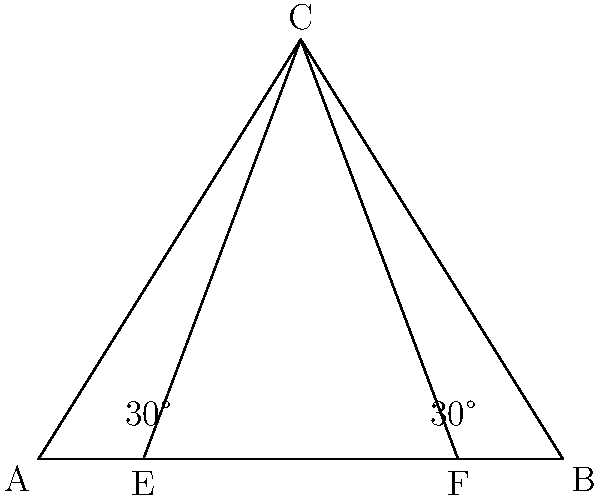In a theater, the stage is represented by line segment AB, which is 10 meters wide. The optimal viewing angle for audience members is 30° on either side of the center. If the apex of this viewing angle (point C) is 8 meters from the center of the stage, what is the maximum width of the seating area (EF) that allows all audience members to have an optimal view? Let's approach this step-by-step:

1) First, we need to identify the triangle formed by the viewing angles. This is an isosceles triangle ABC, where AC = BC.

2) We're given that AB = 10 meters and the height of the triangle (from C to the midpoint of AB) is 8 meters.

3) The angle at C is 60° (30° on each side of the center line).

4) We can split this isosceles triangle into two right triangles. Let's focus on one of these right triangles.

5) In this right triangle, we know:
   - The angle at C is 30°
   - The adjacent side (height) is 8 meters

6) We can use the tangent function to find half of AB:

   $$\tan(30°) = \frac{\text{opposite}}{\text{adjacent}} = \frac{\text{half of AB}}{8}$$

7) We know that $\tan(30°) = \frac{1}{\sqrt{3}}$, so:

   $$\frac{1}{\sqrt{3}} = \frac{\text{half of AB}}{8}$$

8) Solving for half of AB:

   $$\text{half of AB} = \frac{8}{\sqrt{3}} \approx 4.62 \text{ meters}$$

9) The full width of AB is twice this, which confirms our given width of 10 meters (approximately).

10) Now, to find EF, we need to extend these lines to where they intersect the stage level:

    $$EF = AB - 2 * (\text{half of AB} - \frac{\text{half of AB}}{2})$$

11) Simplifying:

    $$EF = 10 - 2 * (4.62 - 2.31) = 10 - 2 * 2.31 = 10 - 4.62 = 5.38 \text{ meters}$$

Therefore, the maximum width of the seating area that allows all audience members to have an optimal view is approximately 5.38 meters.
Answer: 5.38 meters 